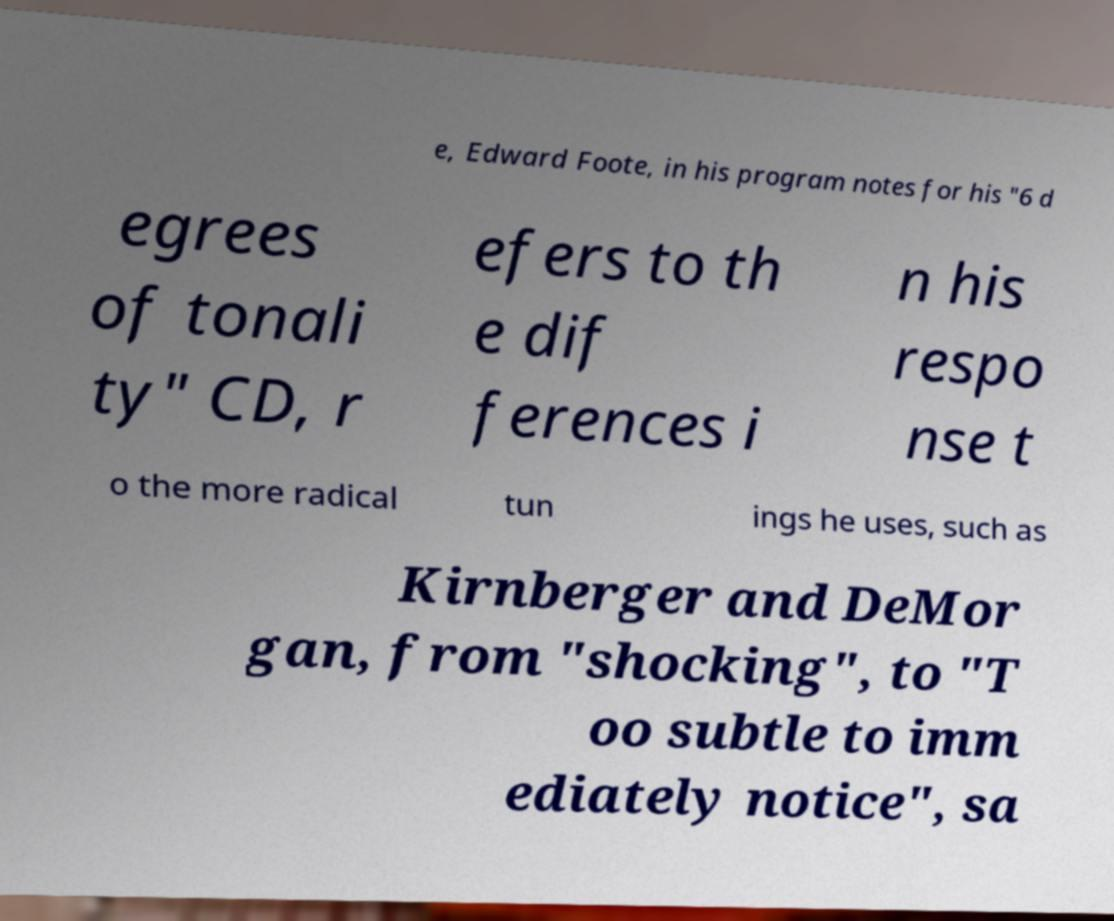Could you assist in decoding the text presented in this image and type it out clearly? e, Edward Foote, in his program notes for his "6 d egrees of tonali ty" CD, r efers to th e dif ferences i n his respo nse t o the more radical tun ings he uses, such as Kirnberger and DeMor gan, from "shocking", to "T oo subtle to imm ediately notice", sa 